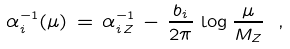<formula> <loc_0><loc_0><loc_500><loc_500>\alpha _ { i } ^ { - 1 } ( \mu ) \, = \, \alpha _ { i \, Z } ^ { - 1 } \, - \, \frac { b _ { i } } { 2 \pi } \, \log \frac { \mu } { M _ { Z } } \ ,</formula> 